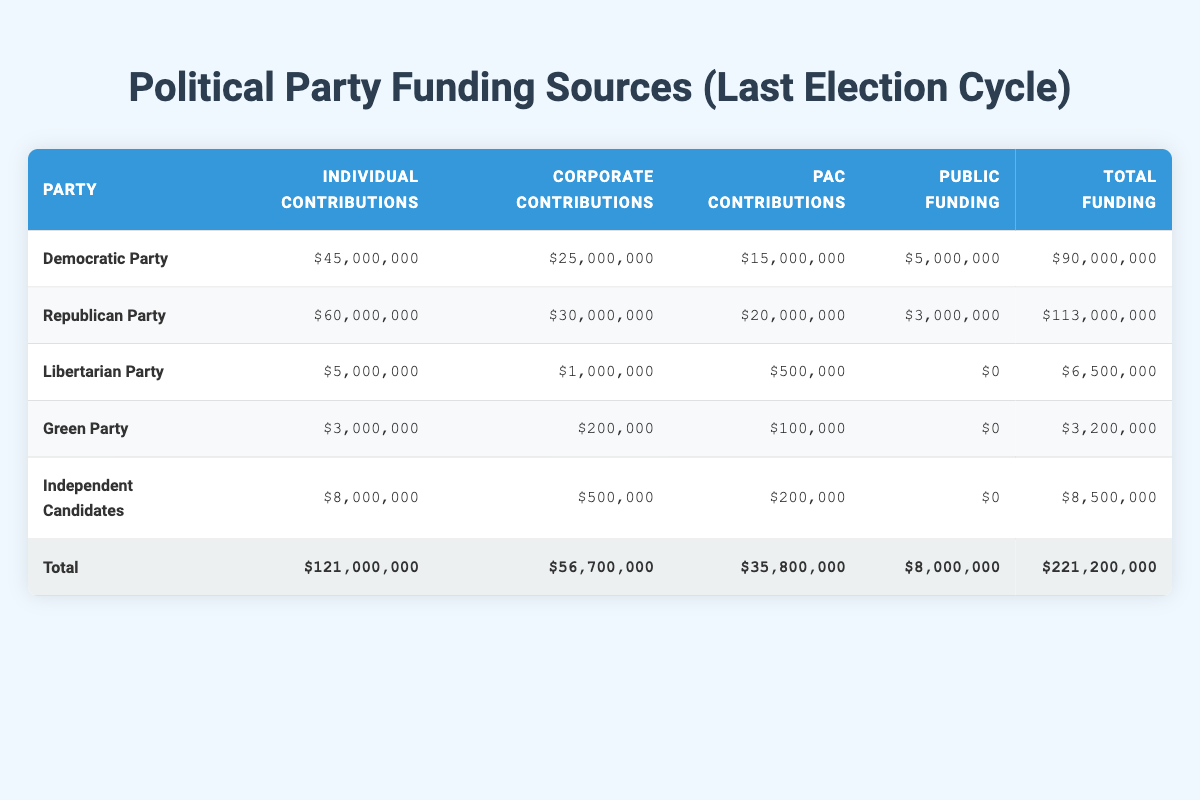What is the total funding for the Republican Party? The total funding for the Republican Party is listed in the last column of the Republican Party row, which shows 113000000.
Answer: 113000000 How much did the Democratic Party receive in individual contributions? Individual contributions for the Democratic Party are found in the second column of the Democratic Party row, which is 45000000.
Answer: 45000000 Which party received the least amount of public funding? The public funding column shows that the Green Party and the Libertarian Party both received 0, which is the least amount.
Answer: Green Party and Libertarian Party What is the combined total of individual contributions for both the Democratic and Republican parties? Adding the individual contributions of both parties gives (45000000 + 60000000) = 105000000.
Answer: 105000000 Did Independent Candidates receive more in total funding than the Libertarian Party? The total funding for Independent Candidates is 8500000, while the total for the Libertarian Party is 6500000. Since 8500000 is greater than 6500000, the statement is true.
Answer: Yes What is the average total funding across all parties listed? The total funding for all parties is 221200000. There are 5 parties, so the average is 221200000 / 5 = 44240000.
Answer: 44240000 How much more did the Republican Party receive in corporate contributions compared to the Democratic Party? The corporate contributions for the Republican Party are 30000000 and for the Democratic Party are 25000000. The difference is (30000000 - 25000000) = 5000000.
Answer: 5000000 Which party had the highest individual contributions and what was the amount? By comparing individual contributions across the parties, the Republican Party has the highest with 60000000.
Answer: Republican Party with 60000000 What percentage of total funding did the PAC contributions account for in the Democratic Party? The PAC contributions for the Democratic Party are 15000000, and the total funding is 90000000. The percentage is (15000000 / 90000000) * 100 = 16.67%.
Answer: 16.67% 